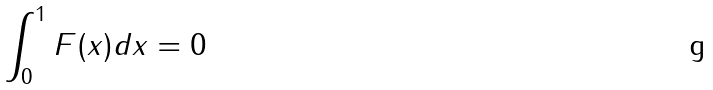<formula> <loc_0><loc_0><loc_500><loc_500>\int _ { 0 } ^ { 1 } F ( x ) d x = 0</formula> 